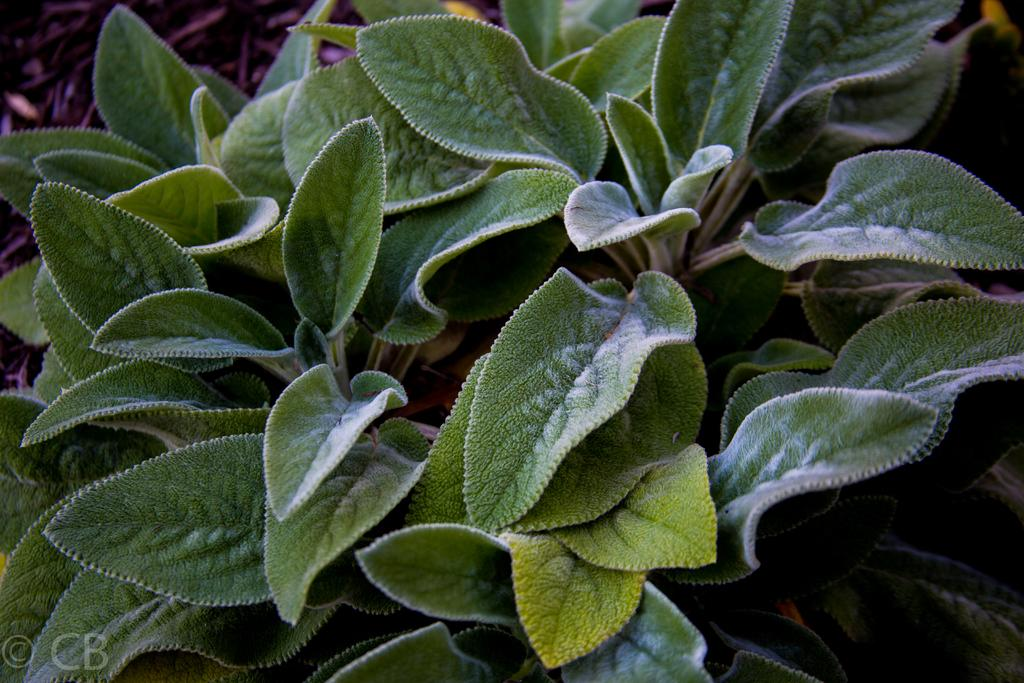What type of living organisms can be seen in the image? Plants can be seen in the image. What type of church can be seen in the image? There is no church present in the image; it only contains plants. What type of nose can be seen on the paper in the image? There is no paper or nose present in the image; it only contains plants. 